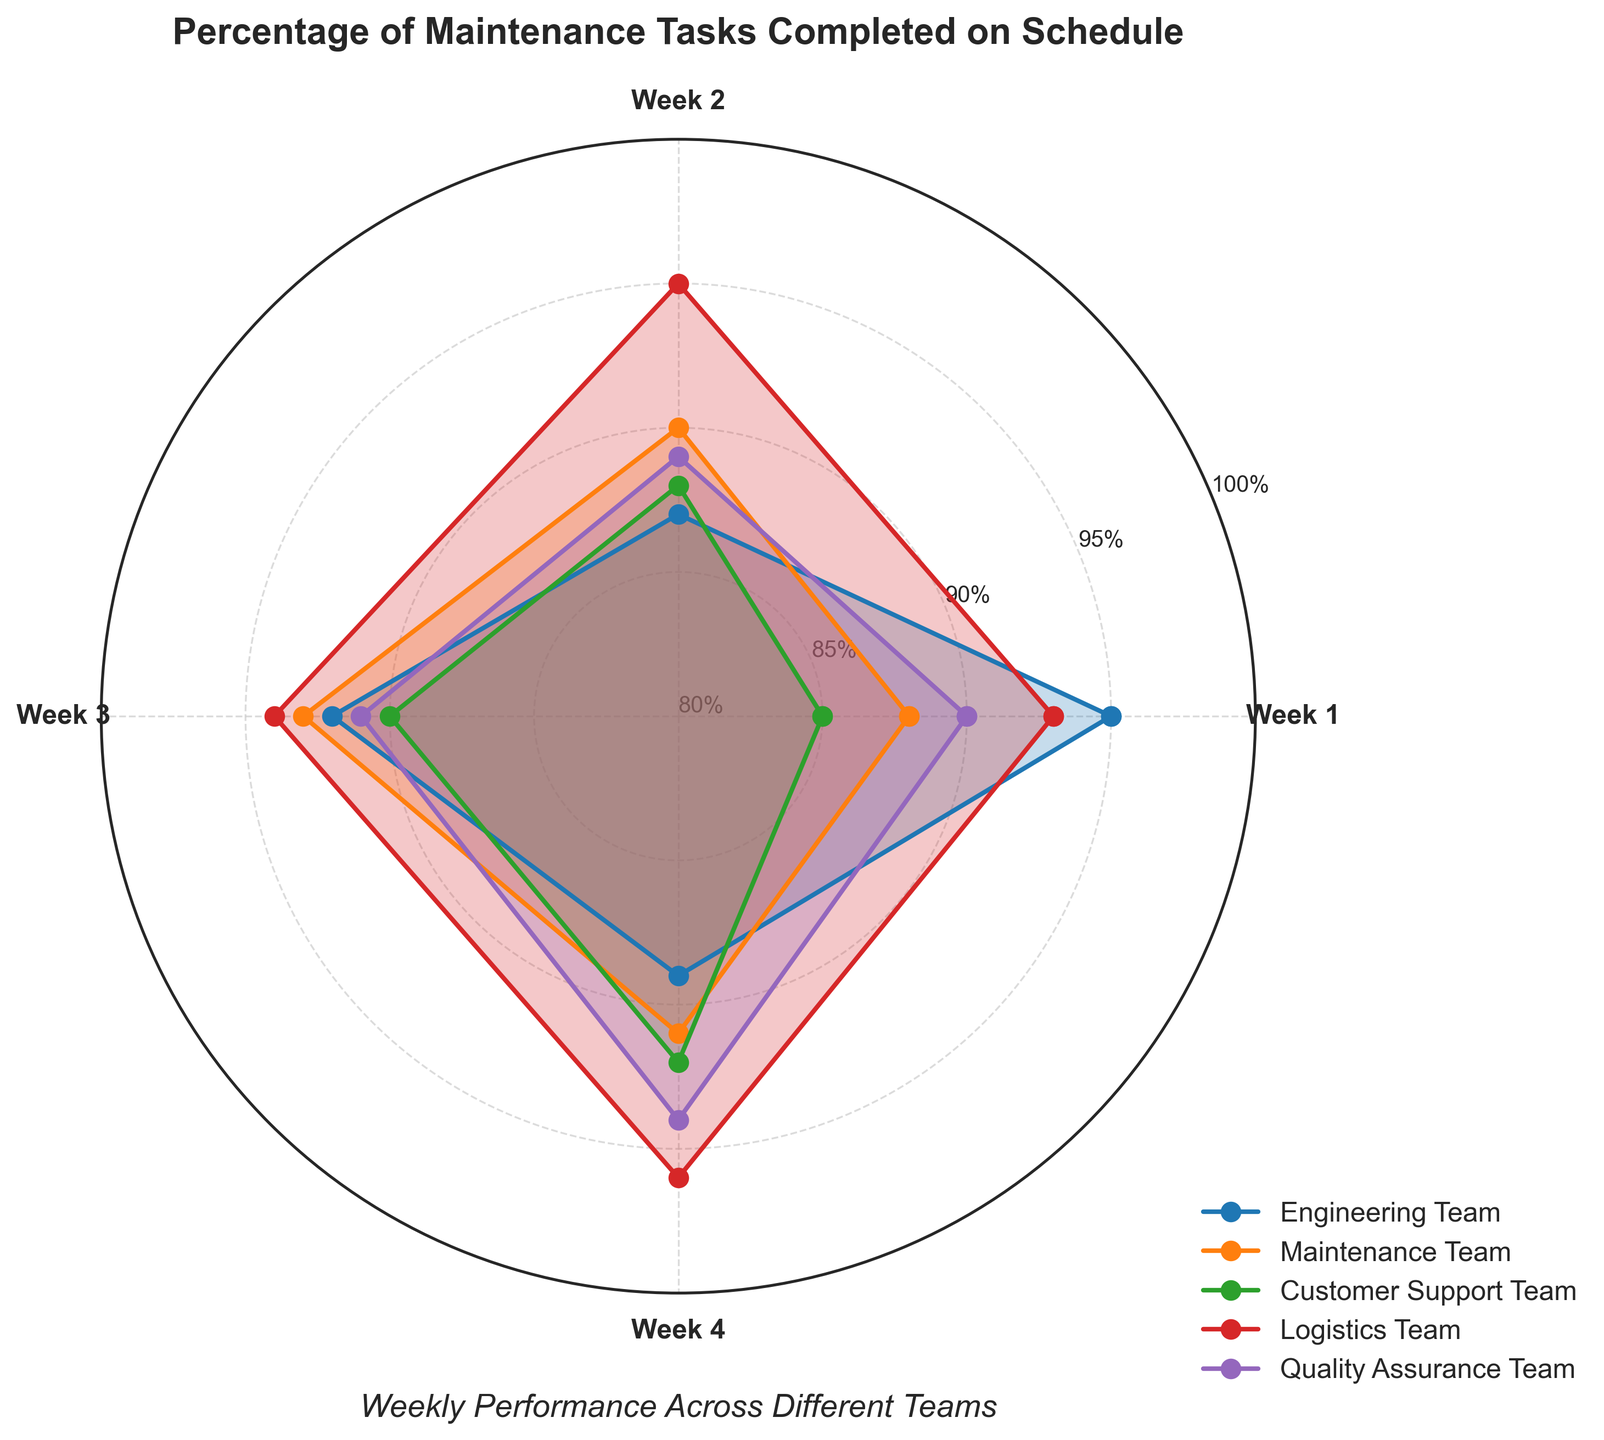Which team has the highest completion percentage in Week 1? Look at the Week 1 values for all the teams and identify the highest percentage. The Logistics Team has 93%.
Answer: Logistics Team What is the average completion percentage for the Maintenance Team across all weeks? Sum the percentages for each week for the Maintenance Team (88, 90, 93, 91) and divide by the number of weeks (4). (88 + 90 + 93 + 91) / 4 = 362 / 4 = 90.5
Answer: 90.5 Which week shows the highest completion percentage for Customer Support Team? Look at the Customer Support Team values and identify the week with the highest value. Week 4 has 92%.
Answer: Week 4 How does the completion percentage of the Engineering Team in Week 3 compare to the Quality Assurance Team in Week 3? Compare the values for Week 3 for both teams. Engineering Team has 92%, Quality Assurance Team has 91%. 92% is higher than 91%.
Answer: Engineering Team is higher What is the overall trend in completion percentage for the Logistics Team? Analyze the completion percentages for each week for the Logistics Team (93, 95, 94, 96). The values are increasing or fluctuating to higher values over time.
Answer: Increasing Across which weeks does the Quality Assurance Team have completion percentages above 90%? Check each week's value for the Quality Assurance Team. Weeks 1, 3, and 4 have values above 90% (90, 91, 94).
Answer: Weeks 1, 3, and 4 Which team shows the most consistency in their weekly completion percentages? Determine the team with the least variation in their weekly values. The Maintenance Team has values (88, 90, 93, 91) which are relatively consistent compared to others.
Answer: Maintenance Team What is the range of completion percentages for the Customer Support Team across all weeks? Subtract the smallest value from the largest value for Customer Support Team (92 - 85 = 7).
Answer: 7 Which team had the greatest improvement from Week 1 to Week 4? Calculate the difference between Week 1 and Week 4 values for each team and identify the greatest improvement. Customer Support Team improved from 85% to 92%, a difference of 7%.
Answer: Customer Support Team What is the minimum completion percentage achieved by any team in any week? Identify the smallest value in the entire dataset. The lowest value across all weeks and teams is 85% from the Customer Support Team in Week 1.
Answer: 85% 